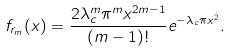<formula> <loc_0><loc_0><loc_500><loc_500>f _ { r _ { m } } ( x ) = \frac { 2 \lambda _ { c } ^ { m } \pi ^ { m } x ^ { 2 m - 1 } } { ( m - 1 ) ! } e ^ { - \lambda _ { c } \pi x ^ { 2 } } .</formula> 